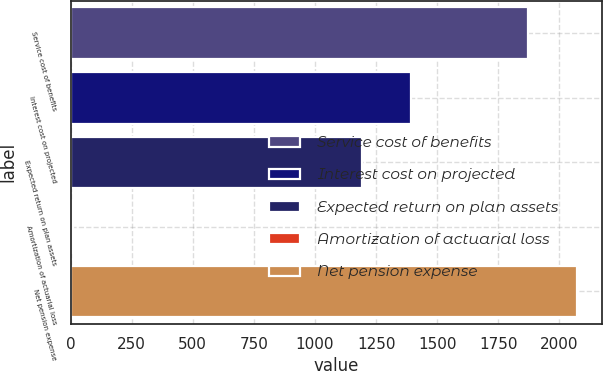<chart> <loc_0><loc_0><loc_500><loc_500><bar_chart><fcel>Service cost of benefits<fcel>Interest cost on projected<fcel>Expected return on plan assets<fcel>Amortization of actuarial loss<fcel>Net pension expense<nl><fcel>1870<fcel>1394.5<fcel>1192<fcel>10<fcel>2072.5<nl></chart> 